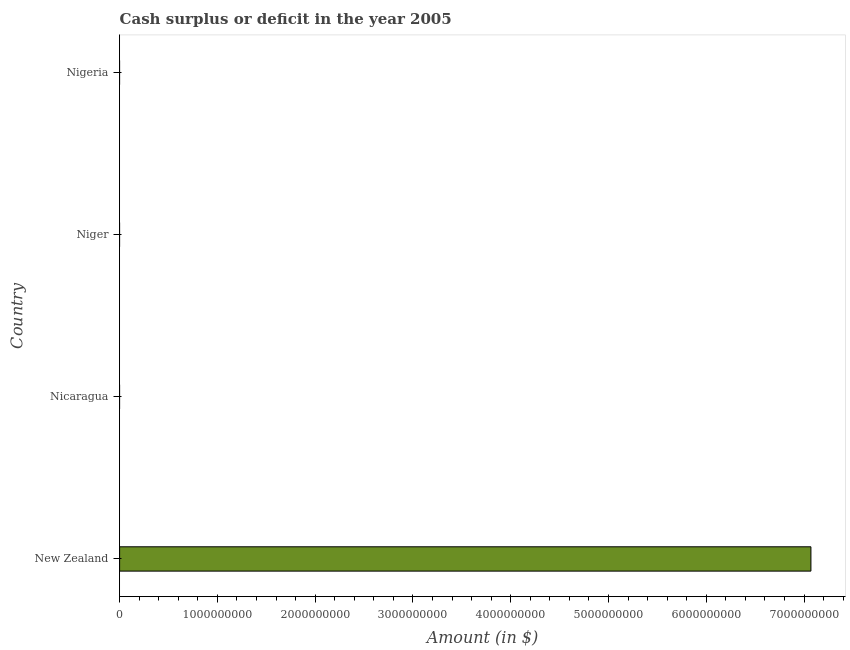What is the title of the graph?
Provide a short and direct response. Cash surplus or deficit in the year 2005. What is the label or title of the X-axis?
Offer a very short reply. Amount (in $). Across all countries, what is the maximum cash surplus or deficit?
Offer a very short reply. 7.07e+09. Across all countries, what is the minimum cash surplus or deficit?
Offer a terse response. 0. In which country was the cash surplus or deficit maximum?
Your answer should be compact. New Zealand. What is the sum of the cash surplus or deficit?
Make the answer very short. 7.07e+09. What is the average cash surplus or deficit per country?
Offer a terse response. 1.77e+09. In how many countries, is the cash surplus or deficit greater than 200000000 $?
Offer a terse response. 1. What is the difference between the highest and the lowest cash surplus or deficit?
Give a very brief answer. 7.07e+09. In how many countries, is the cash surplus or deficit greater than the average cash surplus or deficit taken over all countries?
Keep it short and to the point. 1. Are all the bars in the graph horizontal?
Keep it short and to the point. Yes. What is the Amount (in $) of New Zealand?
Keep it short and to the point. 7.07e+09. What is the Amount (in $) of Nicaragua?
Offer a very short reply. 0. What is the Amount (in $) in Nigeria?
Ensure brevity in your answer.  0. 